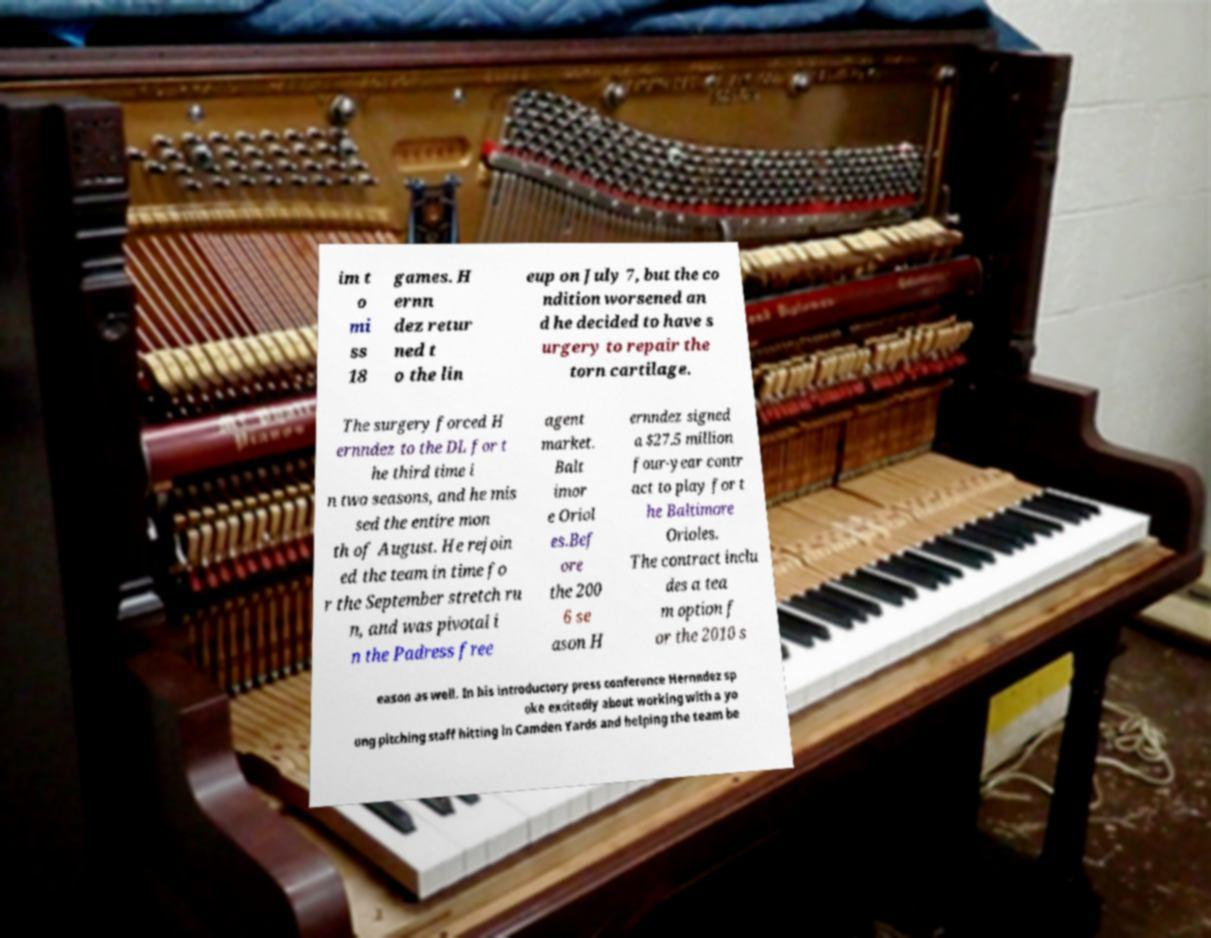Could you assist in decoding the text presented in this image and type it out clearly? im t o mi ss 18 games. H ernn dez retur ned t o the lin eup on July 7, but the co ndition worsened an d he decided to have s urgery to repair the torn cartilage. The surgery forced H ernndez to the DL for t he third time i n two seasons, and he mis sed the entire mon th of August. He rejoin ed the team in time fo r the September stretch ru n, and was pivotal i n the Padress free agent market. Balt imor e Oriol es.Bef ore the 200 6 se ason H ernndez signed a $27.5 million four-year contr act to play for t he Baltimore Orioles. The contract inclu des a tea m option f or the 2010 s eason as well. In his introductory press conference Hernndez sp oke excitedly about working with a yo ung pitching staff hitting in Camden Yards and helping the team be 